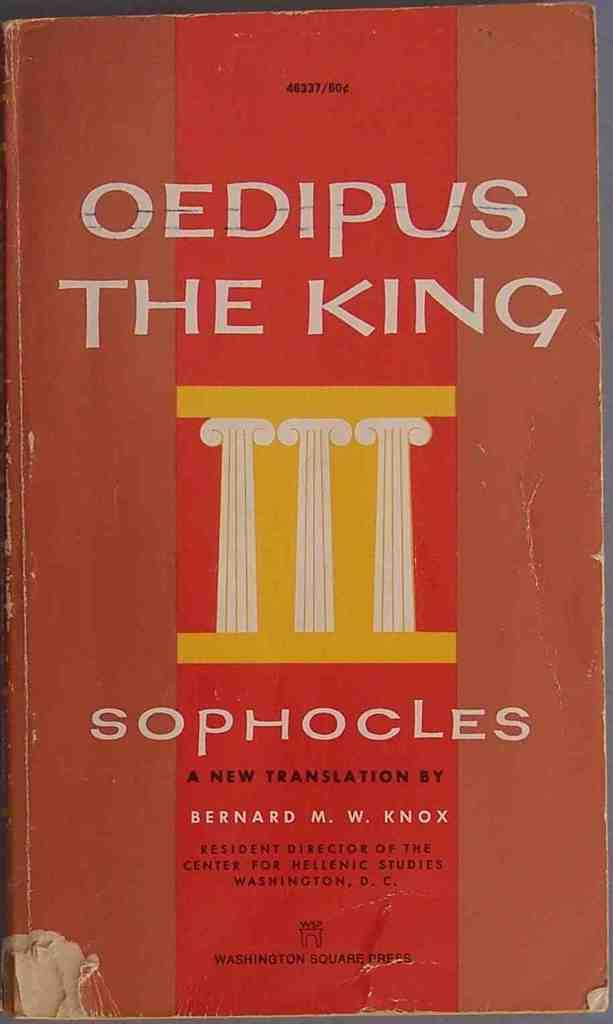<image>
Offer a succinct explanation of the picture presented. The book Oedpus: The King, written by Bernard M. W. Knox. 